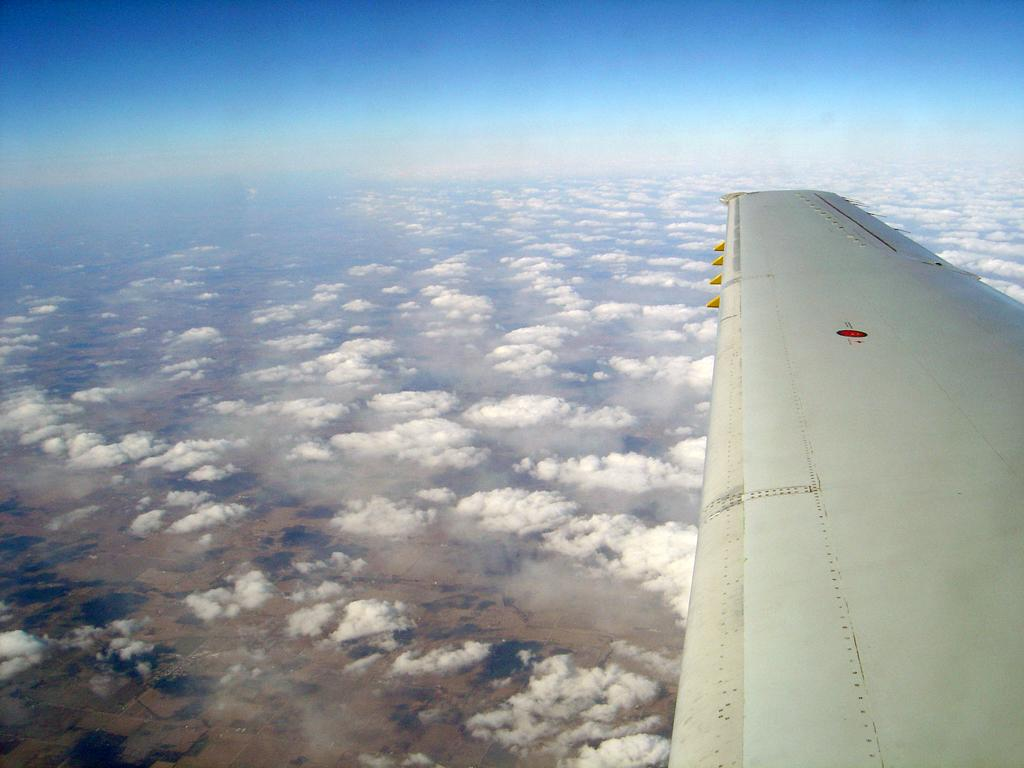What is located on the right side of the image? There is a wing of an airplane on the right side of the image. What can be seen in the background of the image? There are clouds visible in the background of the image. What type of hair is visible on the carriage in the image? There is no carriage or hair present in the image; it only features a wing of an airplane and clouds in the background. 